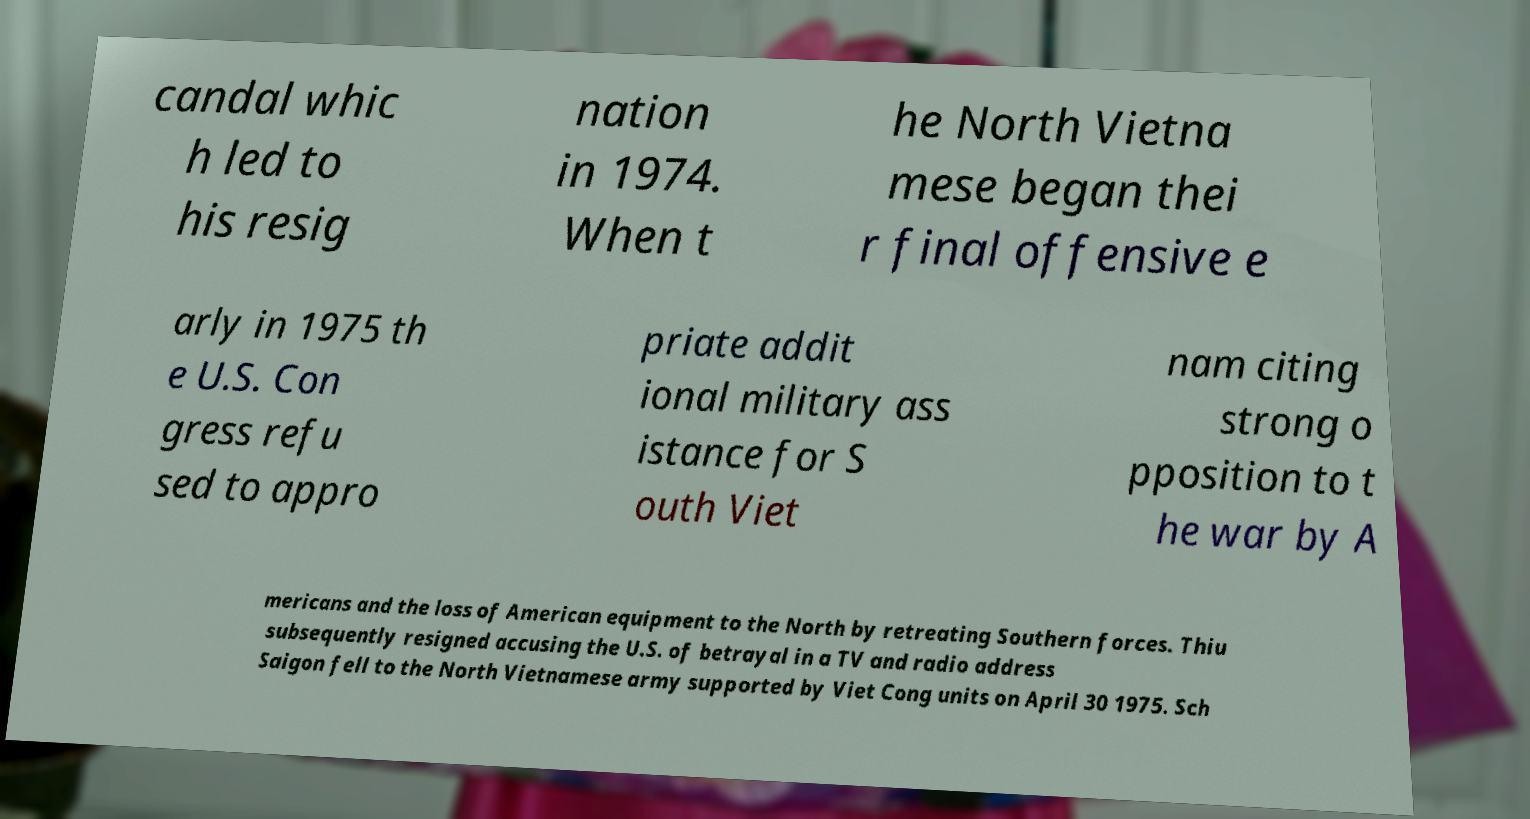For documentation purposes, I need the text within this image transcribed. Could you provide that? candal whic h led to his resig nation in 1974. When t he North Vietna mese began thei r final offensive e arly in 1975 th e U.S. Con gress refu sed to appro priate addit ional military ass istance for S outh Viet nam citing strong o pposition to t he war by A mericans and the loss of American equipment to the North by retreating Southern forces. Thiu subsequently resigned accusing the U.S. of betrayal in a TV and radio address Saigon fell to the North Vietnamese army supported by Viet Cong units on April 30 1975. Sch 